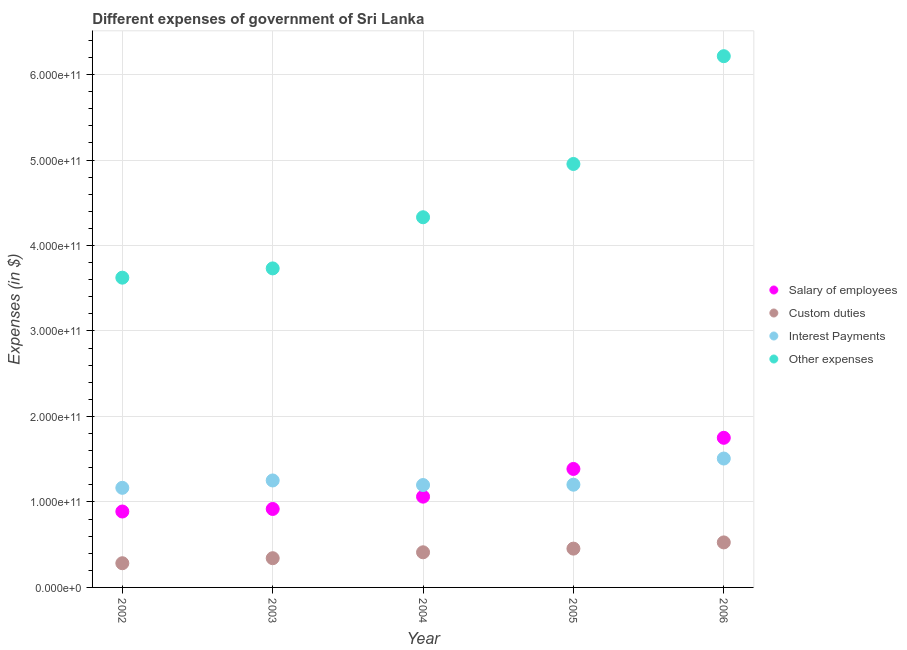How many different coloured dotlines are there?
Offer a terse response. 4. What is the amount spent on other expenses in 2003?
Your answer should be very brief. 3.73e+11. Across all years, what is the maximum amount spent on salary of employees?
Give a very brief answer. 1.75e+11. Across all years, what is the minimum amount spent on interest payments?
Your answer should be very brief. 1.17e+11. In which year was the amount spent on interest payments maximum?
Make the answer very short. 2006. In which year was the amount spent on custom duties minimum?
Your answer should be very brief. 2002. What is the total amount spent on salary of employees in the graph?
Ensure brevity in your answer.  6.00e+11. What is the difference between the amount spent on other expenses in 2002 and that in 2006?
Ensure brevity in your answer.  -2.59e+11. What is the difference between the amount spent on salary of employees in 2003 and the amount spent on interest payments in 2005?
Offer a very short reply. -2.84e+1. What is the average amount spent on interest payments per year?
Your response must be concise. 1.26e+11. In the year 2004, what is the difference between the amount spent on salary of employees and amount spent on custom duties?
Your answer should be compact. 6.51e+1. In how many years, is the amount spent on custom duties greater than 120000000000 $?
Ensure brevity in your answer.  0. What is the ratio of the amount spent on other expenses in 2004 to that in 2005?
Give a very brief answer. 0.87. Is the amount spent on custom duties in 2004 less than that in 2005?
Provide a succinct answer. Yes. What is the difference between the highest and the second highest amount spent on interest payments?
Make the answer very short. 2.57e+1. What is the difference between the highest and the lowest amount spent on interest payments?
Keep it short and to the point. 3.43e+1. Is it the case that in every year, the sum of the amount spent on custom duties and amount spent on salary of employees is greater than the sum of amount spent on interest payments and amount spent on other expenses?
Ensure brevity in your answer.  No. What is the difference between two consecutive major ticks on the Y-axis?
Offer a terse response. 1.00e+11. Are the values on the major ticks of Y-axis written in scientific E-notation?
Your answer should be compact. Yes. Does the graph contain grids?
Offer a terse response. Yes. How many legend labels are there?
Give a very brief answer. 4. How are the legend labels stacked?
Offer a terse response. Vertical. What is the title of the graph?
Offer a terse response. Different expenses of government of Sri Lanka. What is the label or title of the Y-axis?
Your answer should be compact. Expenses (in $). What is the Expenses (in $) of Salary of employees in 2002?
Give a very brief answer. 8.88e+1. What is the Expenses (in $) in Custom duties in 2002?
Ensure brevity in your answer.  2.83e+1. What is the Expenses (in $) of Interest Payments in 2002?
Give a very brief answer. 1.17e+11. What is the Expenses (in $) in Other expenses in 2002?
Your answer should be compact. 3.62e+11. What is the Expenses (in $) of Salary of employees in 2003?
Offer a very short reply. 9.18e+1. What is the Expenses (in $) of Custom duties in 2003?
Give a very brief answer. 3.42e+1. What is the Expenses (in $) in Interest Payments in 2003?
Keep it short and to the point. 1.25e+11. What is the Expenses (in $) in Other expenses in 2003?
Offer a terse response. 3.73e+11. What is the Expenses (in $) of Salary of employees in 2004?
Your response must be concise. 1.06e+11. What is the Expenses (in $) of Custom duties in 2004?
Provide a succinct answer. 4.11e+1. What is the Expenses (in $) of Interest Payments in 2004?
Provide a short and direct response. 1.20e+11. What is the Expenses (in $) of Other expenses in 2004?
Your answer should be compact. 4.33e+11. What is the Expenses (in $) in Salary of employees in 2005?
Provide a succinct answer. 1.39e+11. What is the Expenses (in $) in Custom duties in 2005?
Offer a terse response. 4.54e+1. What is the Expenses (in $) of Interest Payments in 2005?
Offer a terse response. 1.20e+11. What is the Expenses (in $) of Other expenses in 2005?
Offer a terse response. 4.95e+11. What is the Expenses (in $) of Salary of employees in 2006?
Give a very brief answer. 1.75e+11. What is the Expenses (in $) of Custom duties in 2006?
Ensure brevity in your answer.  5.27e+1. What is the Expenses (in $) in Interest Payments in 2006?
Your response must be concise. 1.51e+11. What is the Expenses (in $) of Other expenses in 2006?
Your answer should be compact. 6.21e+11. Across all years, what is the maximum Expenses (in $) in Salary of employees?
Make the answer very short. 1.75e+11. Across all years, what is the maximum Expenses (in $) in Custom duties?
Your answer should be very brief. 5.27e+1. Across all years, what is the maximum Expenses (in $) in Interest Payments?
Your response must be concise. 1.51e+11. Across all years, what is the maximum Expenses (in $) in Other expenses?
Ensure brevity in your answer.  6.21e+11. Across all years, what is the minimum Expenses (in $) of Salary of employees?
Your response must be concise. 8.88e+1. Across all years, what is the minimum Expenses (in $) of Custom duties?
Offer a very short reply. 2.83e+1. Across all years, what is the minimum Expenses (in $) of Interest Payments?
Your answer should be very brief. 1.17e+11. Across all years, what is the minimum Expenses (in $) in Other expenses?
Offer a very short reply. 3.62e+11. What is the total Expenses (in $) of Salary of employees in the graph?
Your answer should be very brief. 6.00e+11. What is the total Expenses (in $) in Custom duties in the graph?
Give a very brief answer. 2.02e+11. What is the total Expenses (in $) of Interest Payments in the graph?
Ensure brevity in your answer.  6.32e+11. What is the total Expenses (in $) in Other expenses in the graph?
Provide a short and direct response. 2.29e+12. What is the difference between the Expenses (in $) in Salary of employees in 2002 and that in 2003?
Make the answer very short. -2.98e+09. What is the difference between the Expenses (in $) of Custom duties in 2002 and that in 2003?
Your answer should be very brief. -5.88e+09. What is the difference between the Expenses (in $) in Interest Payments in 2002 and that in 2003?
Your answer should be compact. -8.61e+09. What is the difference between the Expenses (in $) in Other expenses in 2002 and that in 2003?
Offer a terse response. -1.08e+1. What is the difference between the Expenses (in $) of Salary of employees in 2002 and that in 2004?
Give a very brief answer. -1.74e+1. What is the difference between the Expenses (in $) in Custom duties in 2002 and that in 2004?
Your response must be concise. -1.28e+1. What is the difference between the Expenses (in $) of Interest Payments in 2002 and that in 2004?
Provide a succinct answer. -3.27e+09. What is the difference between the Expenses (in $) in Other expenses in 2002 and that in 2004?
Provide a short and direct response. -7.07e+1. What is the difference between the Expenses (in $) of Salary of employees in 2002 and that in 2005?
Provide a short and direct response. -4.98e+1. What is the difference between the Expenses (in $) of Custom duties in 2002 and that in 2005?
Offer a very short reply. -1.71e+1. What is the difference between the Expenses (in $) in Interest Payments in 2002 and that in 2005?
Make the answer very short. -3.64e+09. What is the difference between the Expenses (in $) of Other expenses in 2002 and that in 2005?
Provide a short and direct response. -1.33e+11. What is the difference between the Expenses (in $) of Salary of employees in 2002 and that in 2006?
Your response must be concise. -8.62e+1. What is the difference between the Expenses (in $) in Custom duties in 2002 and that in 2006?
Provide a short and direct response. -2.44e+1. What is the difference between the Expenses (in $) in Interest Payments in 2002 and that in 2006?
Provide a succinct answer. -3.43e+1. What is the difference between the Expenses (in $) of Other expenses in 2002 and that in 2006?
Your response must be concise. -2.59e+11. What is the difference between the Expenses (in $) in Salary of employees in 2003 and that in 2004?
Give a very brief answer. -1.44e+1. What is the difference between the Expenses (in $) in Custom duties in 2003 and that in 2004?
Your response must be concise. -6.91e+09. What is the difference between the Expenses (in $) in Interest Payments in 2003 and that in 2004?
Your answer should be very brief. 5.34e+09. What is the difference between the Expenses (in $) of Other expenses in 2003 and that in 2004?
Give a very brief answer. -5.98e+1. What is the difference between the Expenses (in $) in Salary of employees in 2003 and that in 2005?
Ensure brevity in your answer.  -4.68e+1. What is the difference between the Expenses (in $) in Custom duties in 2003 and that in 2005?
Keep it short and to the point. -1.12e+1. What is the difference between the Expenses (in $) in Interest Payments in 2003 and that in 2005?
Provide a succinct answer. 4.97e+09. What is the difference between the Expenses (in $) in Other expenses in 2003 and that in 2005?
Ensure brevity in your answer.  -1.22e+11. What is the difference between the Expenses (in $) in Salary of employees in 2003 and that in 2006?
Keep it short and to the point. -8.32e+1. What is the difference between the Expenses (in $) in Custom duties in 2003 and that in 2006?
Ensure brevity in your answer.  -1.85e+1. What is the difference between the Expenses (in $) in Interest Payments in 2003 and that in 2006?
Your answer should be very brief. -2.57e+1. What is the difference between the Expenses (in $) in Other expenses in 2003 and that in 2006?
Keep it short and to the point. -2.48e+11. What is the difference between the Expenses (in $) of Salary of employees in 2004 and that in 2005?
Provide a succinct answer. -3.24e+1. What is the difference between the Expenses (in $) of Custom duties in 2004 and that in 2005?
Your answer should be compact. -4.29e+09. What is the difference between the Expenses (in $) in Interest Payments in 2004 and that in 2005?
Ensure brevity in your answer.  -3.77e+08. What is the difference between the Expenses (in $) of Other expenses in 2004 and that in 2005?
Ensure brevity in your answer.  -6.23e+1. What is the difference between the Expenses (in $) in Salary of employees in 2004 and that in 2006?
Provide a short and direct response. -6.88e+1. What is the difference between the Expenses (in $) of Custom duties in 2004 and that in 2006?
Offer a very short reply. -1.16e+1. What is the difference between the Expenses (in $) of Interest Payments in 2004 and that in 2006?
Ensure brevity in your answer.  -3.10e+1. What is the difference between the Expenses (in $) of Other expenses in 2004 and that in 2006?
Provide a succinct answer. -1.88e+11. What is the difference between the Expenses (in $) of Salary of employees in 2005 and that in 2006?
Keep it short and to the point. -3.64e+1. What is the difference between the Expenses (in $) in Custom duties in 2005 and that in 2006?
Give a very brief answer. -7.27e+09. What is the difference between the Expenses (in $) of Interest Payments in 2005 and that in 2006?
Offer a terse response. -3.06e+1. What is the difference between the Expenses (in $) of Other expenses in 2005 and that in 2006?
Your answer should be compact. -1.26e+11. What is the difference between the Expenses (in $) of Salary of employees in 2002 and the Expenses (in $) of Custom duties in 2003?
Your answer should be compact. 5.46e+1. What is the difference between the Expenses (in $) of Salary of employees in 2002 and the Expenses (in $) of Interest Payments in 2003?
Your answer should be compact. -3.63e+1. What is the difference between the Expenses (in $) of Salary of employees in 2002 and the Expenses (in $) of Other expenses in 2003?
Give a very brief answer. -2.84e+11. What is the difference between the Expenses (in $) of Custom duties in 2002 and the Expenses (in $) of Interest Payments in 2003?
Make the answer very short. -9.68e+1. What is the difference between the Expenses (in $) in Custom duties in 2002 and the Expenses (in $) in Other expenses in 2003?
Give a very brief answer. -3.45e+11. What is the difference between the Expenses (in $) in Interest Payments in 2002 and the Expenses (in $) in Other expenses in 2003?
Keep it short and to the point. -2.57e+11. What is the difference between the Expenses (in $) in Salary of employees in 2002 and the Expenses (in $) in Custom duties in 2004?
Offer a terse response. 4.77e+1. What is the difference between the Expenses (in $) in Salary of employees in 2002 and the Expenses (in $) in Interest Payments in 2004?
Ensure brevity in your answer.  -3.10e+1. What is the difference between the Expenses (in $) of Salary of employees in 2002 and the Expenses (in $) of Other expenses in 2004?
Ensure brevity in your answer.  -3.44e+11. What is the difference between the Expenses (in $) of Custom duties in 2002 and the Expenses (in $) of Interest Payments in 2004?
Your answer should be compact. -9.15e+1. What is the difference between the Expenses (in $) in Custom duties in 2002 and the Expenses (in $) in Other expenses in 2004?
Provide a succinct answer. -4.05e+11. What is the difference between the Expenses (in $) of Interest Payments in 2002 and the Expenses (in $) of Other expenses in 2004?
Ensure brevity in your answer.  -3.17e+11. What is the difference between the Expenses (in $) in Salary of employees in 2002 and the Expenses (in $) in Custom duties in 2005?
Give a very brief answer. 4.34e+1. What is the difference between the Expenses (in $) in Salary of employees in 2002 and the Expenses (in $) in Interest Payments in 2005?
Ensure brevity in your answer.  -3.14e+1. What is the difference between the Expenses (in $) of Salary of employees in 2002 and the Expenses (in $) of Other expenses in 2005?
Offer a very short reply. -4.07e+11. What is the difference between the Expenses (in $) in Custom duties in 2002 and the Expenses (in $) in Interest Payments in 2005?
Your answer should be compact. -9.19e+1. What is the difference between the Expenses (in $) in Custom duties in 2002 and the Expenses (in $) in Other expenses in 2005?
Keep it short and to the point. -4.67e+11. What is the difference between the Expenses (in $) of Interest Payments in 2002 and the Expenses (in $) of Other expenses in 2005?
Provide a short and direct response. -3.79e+11. What is the difference between the Expenses (in $) in Salary of employees in 2002 and the Expenses (in $) in Custom duties in 2006?
Your response must be concise. 3.61e+1. What is the difference between the Expenses (in $) of Salary of employees in 2002 and the Expenses (in $) of Interest Payments in 2006?
Make the answer very short. -6.20e+1. What is the difference between the Expenses (in $) of Salary of employees in 2002 and the Expenses (in $) of Other expenses in 2006?
Ensure brevity in your answer.  -5.33e+11. What is the difference between the Expenses (in $) in Custom duties in 2002 and the Expenses (in $) in Interest Payments in 2006?
Your answer should be very brief. -1.22e+11. What is the difference between the Expenses (in $) in Custom duties in 2002 and the Expenses (in $) in Other expenses in 2006?
Keep it short and to the point. -5.93e+11. What is the difference between the Expenses (in $) in Interest Payments in 2002 and the Expenses (in $) in Other expenses in 2006?
Offer a terse response. -5.05e+11. What is the difference between the Expenses (in $) in Salary of employees in 2003 and the Expenses (in $) in Custom duties in 2004?
Your answer should be compact. 5.07e+1. What is the difference between the Expenses (in $) of Salary of employees in 2003 and the Expenses (in $) of Interest Payments in 2004?
Offer a terse response. -2.80e+1. What is the difference between the Expenses (in $) in Salary of employees in 2003 and the Expenses (in $) in Other expenses in 2004?
Keep it short and to the point. -3.41e+11. What is the difference between the Expenses (in $) in Custom duties in 2003 and the Expenses (in $) in Interest Payments in 2004?
Give a very brief answer. -8.56e+1. What is the difference between the Expenses (in $) of Custom duties in 2003 and the Expenses (in $) of Other expenses in 2004?
Provide a short and direct response. -3.99e+11. What is the difference between the Expenses (in $) in Interest Payments in 2003 and the Expenses (in $) in Other expenses in 2004?
Provide a short and direct response. -3.08e+11. What is the difference between the Expenses (in $) in Salary of employees in 2003 and the Expenses (in $) in Custom duties in 2005?
Ensure brevity in your answer.  4.64e+1. What is the difference between the Expenses (in $) of Salary of employees in 2003 and the Expenses (in $) of Interest Payments in 2005?
Your answer should be very brief. -2.84e+1. What is the difference between the Expenses (in $) of Salary of employees in 2003 and the Expenses (in $) of Other expenses in 2005?
Offer a very short reply. -4.04e+11. What is the difference between the Expenses (in $) in Custom duties in 2003 and the Expenses (in $) in Interest Payments in 2005?
Ensure brevity in your answer.  -8.60e+1. What is the difference between the Expenses (in $) of Custom duties in 2003 and the Expenses (in $) of Other expenses in 2005?
Provide a short and direct response. -4.61e+11. What is the difference between the Expenses (in $) of Interest Payments in 2003 and the Expenses (in $) of Other expenses in 2005?
Make the answer very short. -3.70e+11. What is the difference between the Expenses (in $) in Salary of employees in 2003 and the Expenses (in $) in Custom duties in 2006?
Your answer should be very brief. 3.91e+1. What is the difference between the Expenses (in $) of Salary of employees in 2003 and the Expenses (in $) of Interest Payments in 2006?
Give a very brief answer. -5.90e+1. What is the difference between the Expenses (in $) in Salary of employees in 2003 and the Expenses (in $) in Other expenses in 2006?
Your answer should be compact. -5.30e+11. What is the difference between the Expenses (in $) in Custom duties in 2003 and the Expenses (in $) in Interest Payments in 2006?
Provide a short and direct response. -1.17e+11. What is the difference between the Expenses (in $) in Custom duties in 2003 and the Expenses (in $) in Other expenses in 2006?
Your response must be concise. -5.87e+11. What is the difference between the Expenses (in $) of Interest Payments in 2003 and the Expenses (in $) of Other expenses in 2006?
Make the answer very short. -4.96e+11. What is the difference between the Expenses (in $) in Salary of employees in 2004 and the Expenses (in $) in Custom duties in 2005?
Make the answer very short. 6.08e+1. What is the difference between the Expenses (in $) of Salary of employees in 2004 and the Expenses (in $) of Interest Payments in 2005?
Offer a terse response. -1.40e+1. What is the difference between the Expenses (in $) of Salary of employees in 2004 and the Expenses (in $) of Other expenses in 2005?
Make the answer very short. -3.89e+11. What is the difference between the Expenses (in $) in Custom duties in 2004 and the Expenses (in $) in Interest Payments in 2005?
Make the answer very short. -7.91e+1. What is the difference between the Expenses (in $) in Custom duties in 2004 and the Expenses (in $) in Other expenses in 2005?
Your answer should be compact. -4.54e+11. What is the difference between the Expenses (in $) of Interest Payments in 2004 and the Expenses (in $) of Other expenses in 2005?
Keep it short and to the point. -3.76e+11. What is the difference between the Expenses (in $) in Salary of employees in 2004 and the Expenses (in $) in Custom duties in 2006?
Keep it short and to the point. 5.35e+1. What is the difference between the Expenses (in $) in Salary of employees in 2004 and the Expenses (in $) in Interest Payments in 2006?
Offer a terse response. -4.46e+1. What is the difference between the Expenses (in $) of Salary of employees in 2004 and the Expenses (in $) of Other expenses in 2006?
Your answer should be very brief. -5.15e+11. What is the difference between the Expenses (in $) in Custom duties in 2004 and the Expenses (in $) in Interest Payments in 2006?
Offer a very short reply. -1.10e+11. What is the difference between the Expenses (in $) in Custom duties in 2004 and the Expenses (in $) in Other expenses in 2006?
Your answer should be very brief. -5.80e+11. What is the difference between the Expenses (in $) of Interest Payments in 2004 and the Expenses (in $) of Other expenses in 2006?
Your answer should be very brief. -5.02e+11. What is the difference between the Expenses (in $) in Salary of employees in 2005 and the Expenses (in $) in Custom duties in 2006?
Your response must be concise. 8.59e+1. What is the difference between the Expenses (in $) of Salary of employees in 2005 and the Expenses (in $) of Interest Payments in 2006?
Provide a short and direct response. -1.22e+1. What is the difference between the Expenses (in $) of Salary of employees in 2005 and the Expenses (in $) of Other expenses in 2006?
Provide a short and direct response. -4.83e+11. What is the difference between the Expenses (in $) in Custom duties in 2005 and the Expenses (in $) in Interest Payments in 2006?
Ensure brevity in your answer.  -1.05e+11. What is the difference between the Expenses (in $) of Custom duties in 2005 and the Expenses (in $) of Other expenses in 2006?
Keep it short and to the point. -5.76e+11. What is the difference between the Expenses (in $) of Interest Payments in 2005 and the Expenses (in $) of Other expenses in 2006?
Make the answer very short. -5.01e+11. What is the average Expenses (in $) in Salary of employees per year?
Your answer should be very brief. 1.20e+11. What is the average Expenses (in $) of Custom duties per year?
Offer a very short reply. 4.03e+1. What is the average Expenses (in $) in Interest Payments per year?
Offer a very short reply. 1.26e+11. What is the average Expenses (in $) in Other expenses per year?
Your response must be concise. 4.57e+11. In the year 2002, what is the difference between the Expenses (in $) in Salary of employees and Expenses (in $) in Custom duties?
Your response must be concise. 6.05e+1. In the year 2002, what is the difference between the Expenses (in $) of Salary of employees and Expenses (in $) of Interest Payments?
Provide a short and direct response. -2.77e+1. In the year 2002, what is the difference between the Expenses (in $) of Salary of employees and Expenses (in $) of Other expenses?
Ensure brevity in your answer.  -2.74e+11. In the year 2002, what is the difference between the Expenses (in $) in Custom duties and Expenses (in $) in Interest Payments?
Your answer should be compact. -8.82e+1. In the year 2002, what is the difference between the Expenses (in $) in Custom duties and Expenses (in $) in Other expenses?
Keep it short and to the point. -3.34e+11. In the year 2002, what is the difference between the Expenses (in $) in Interest Payments and Expenses (in $) in Other expenses?
Your response must be concise. -2.46e+11. In the year 2003, what is the difference between the Expenses (in $) of Salary of employees and Expenses (in $) of Custom duties?
Give a very brief answer. 5.76e+1. In the year 2003, what is the difference between the Expenses (in $) of Salary of employees and Expenses (in $) of Interest Payments?
Provide a succinct answer. -3.33e+1. In the year 2003, what is the difference between the Expenses (in $) of Salary of employees and Expenses (in $) of Other expenses?
Your response must be concise. -2.81e+11. In the year 2003, what is the difference between the Expenses (in $) of Custom duties and Expenses (in $) of Interest Payments?
Offer a very short reply. -9.09e+1. In the year 2003, what is the difference between the Expenses (in $) in Custom duties and Expenses (in $) in Other expenses?
Your response must be concise. -3.39e+11. In the year 2003, what is the difference between the Expenses (in $) in Interest Payments and Expenses (in $) in Other expenses?
Offer a terse response. -2.48e+11. In the year 2004, what is the difference between the Expenses (in $) in Salary of employees and Expenses (in $) in Custom duties?
Provide a succinct answer. 6.51e+1. In the year 2004, what is the difference between the Expenses (in $) of Salary of employees and Expenses (in $) of Interest Payments?
Make the answer very short. -1.36e+1. In the year 2004, what is the difference between the Expenses (in $) in Salary of employees and Expenses (in $) in Other expenses?
Make the answer very short. -3.27e+11. In the year 2004, what is the difference between the Expenses (in $) in Custom duties and Expenses (in $) in Interest Payments?
Offer a terse response. -7.87e+1. In the year 2004, what is the difference between the Expenses (in $) of Custom duties and Expenses (in $) of Other expenses?
Ensure brevity in your answer.  -3.92e+11. In the year 2004, what is the difference between the Expenses (in $) in Interest Payments and Expenses (in $) in Other expenses?
Offer a terse response. -3.13e+11. In the year 2005, what is the difference between the Expenses (in $) of Salary of employees and Expenses (in $) of Custom duties?
Provide a succinct answer. 9.32e+1. In the year 2005, what is the difference between the Expenses (in $) of Salary of employees and Expenses (in $) of Interest Payments?
Provide a short and direct response. 1.84e+1. In the year 2005, what is the difference between the Expenses (in $) in Salary of employees and Expenses (in $) in Other expenses?
Offer a terse response. -3.57e+11. In the year 2005, what is the difference between the Expenses (in $) in Custom duties and Expenses (in $) in Interest Payments?
Provide a short and direct response. -7.48e+1. In the year 2005, what is the difference between the Expenses (in $) of Custom duties and Expenses (in $) of Other expenses?
Your answer should be very brief. -4.50e+11. In the year 2005, what is the difference between the Expenses (in $) of Interest Payments and Expenses (in $) of Other expenses?
Give a very brief answer. -3.75e+11. In the year 2006, what is the difference between the Expenses (in $) in Salary of employees and Expenses (in $) in Custom duties?
Offer a very short reply. 1.22e+11. In the year 2006, what is the difference between the Expenses (in $) in Salary of employees and Expenses (in $) in Interest Payments?
Give a very brief answer. 2.43e+1. In the year 2006, what is the difference between the Expenses (in $) of Salary of employees and Expenses (in $) of Other expenses?
Make the answer very short. -4.46e+11. In the year 2006, what is the difference between the Expenses (in $) of Custom duties and Expenses (in $) of Interest Payments?
Your answer should be compact. -9.81e+1. In the year 2006, what is the difference between the Expenses (in $) of Custom duties and Expenses (in $) of Other expenses?
Your answer should be very brief. -5.69e+11. In the year 2006, what is the difference between the Expenses (in $) in Interest Payments and Expenses (in $) in Other expenses?
Keep it short and to the point. -4.71e+11. What is the ratio of the Expenses (in $) of Salary of employees in 2002 to that in 2003?
Make the answer very short. 0.97. What is the ratio of the Expenses (in $) in Custom duties in 2002 to that in 2003?
Give a very brief answer. 0.83. What is the ratio of the Expenses (in $) in Interest Payments in 2002 to that in 2003?
Provide a short and direct response. 0.93. What is the ratio of the Expenses (in $) in Salary of employees in 2002 to that in 2004?
Offer a very short reply. 0.84. What is the ratio of the Expenses (in $) of Custom duties in 2002 to that in 2004?
Offer a very short reply. 0.69. What is the ratio of the Expenses (in $) of Interest Payments in 2002 to that in 2004?
Offer a very short reply. 0.97. What is the ratio of the Expenses (in $) of Other expenses in 2002 to that in 2004?
Provide a short and direct response. 0.84. What is the ratio of the Expenses (in $) in Salary of employees in 2002 to that in 2005?
Keep it short and to the point. 0.64. What is the ratio of the Expenses (in $) in Custom duties in 2002 to that in 2005?
Make the answer very short. 0.62. What is the ratio of the Expenses (in $) of Interest Payments in 2002 to that in 2005?
Ensure brevity in your answer.  0.97. What is the ratio of the Expenses (in $) in Other expenses in 2002 to that in 2005?
Ensure brevity in your answer.  0.73. What is the ratio of the Expenses (in $) of Salary of employees in 2002 to that in 2006?
Your response must be concise. 0.51. What is the ratio of the Expenses (in $) of Custom duties in 2002 to that in 2006?
Offer a very short reply. 0.54. What is the ratio of the Expenses (in $) in Interest Payments in 2002 to that in 2006?
Your response must be concise. 0.77. What is the ratio of the Expenses (in $) in Other expenses in 2002 to that in 2006?
Offer a very short reply. 0.58. What is the ratio of the Expenses (in $) in Salary of employees in 2003 to that in 2004?
Give a very brief answer. 0.86. What is the ratio of the Expenses (in $) in Custom duties in 2003 to that in 2004?
Offer a very short reply. 0.83. What is the ratio of the Expenses (in $) in Interest Payments in 2003 to that in 2004?
Your answer should be very brief. 1.04. What is the ratio of the Expenses (in $) in Other expenses in 2003 to that in 2004?
Your response must be concise. 0.86. What is the ratio of the Expenses (in $) of Salary of employees in 2003 to that in 2005?
Provide a succinct answer. 0.66. What is the ratio of the Expenses (in $) of Custom duties in 2003 to that in 2005?
Your answer should be very brief. 0.75. What is the ratio of the Expenses (in $) in Interest Payments in 2003 to that in 2005?
Give a very brief answer. 1.04. What is the ratio of the Expenses (in $) in Other expenses in 2003 to that in 2005?
Keep it short and to the point. 0.75. What is the ratio of the Expenses (in $) of Salary of employees in 2003 to that in 2006?
Offer a very short reply. 0.52. What is the ratio of the Expenses (in $) of Custom duties in 2003 to that in 2006?
Provide a succinct answer. 0.65. What is the ratio of the Expenses (in $) of Interest Payments in 2003 to that in 2006?
Your answer should be compact. 0.83. What is the ratio of the Expenses (in $) in Other expenses in 2003 to that in 2006?
Make the answer very short. 0.6. What is the ratio of the Expenses (in $) in Salary of employees in 2004 to that in 2005?
Your answer should be compact. 0.77. What is the ratio of the Expenses (in $) of Custom duties in 2004 to that in 2005?
Your response must be concise. 0.91. What is the ratio of the Expenses (in $) of Interest Payments in 2004 to that in 2005?
Your answer should be compact. 1. What is the ratio of the Expenses (in $) in Other expenses in 2004 to that in 2005?
Make the answer very short. 0.87. What is the ratio of the Expenses (in $) of Salary of employees in 2004 to that in 2006?
Offer a very short reply. 0.61. What is the ratio of the Expenses (in $) of Custom duties in 2004 to that in 2006?
Provide a short and direct response. 0.78. What is the ratio of the Expenses (in $) of Interest Payments in 2004 to that in 2006?
Your response must be concise. 0.79. What is the ratio of the Expenses (in $) in Other expenses in 2004 to that in 2006?
Provide a short and direct response. 0.7. What is the ratio of the Expenses (in $) in Salary of employees in 2005 to that in 2006?
Offer a terse response. 0.79. What is the ratio of the Expenses (in $) of Custom duties in 2005 to that in 2006?
Keep it short and to the point. 0.86. What is the ratio of the Expenses (in $) of Interest Payments in 2005 to that in 2006?
Ensure brevity in your answer.  0.8. What is the ratio of the Expenses (in $) of Other expenses in 2005 to that in 2006?
Offer a very short reply. 0.8. What is the difference between the highest and the second highest Expenses (in $) of Salary of employees?
Offer a terse response. 3.64e+1. What is the difference between the highest and the second highest Expenses (in $) in Custom duties?
Offer a terse response. 7.27e+09. What is the difference between the highest and the second highest Expenses (in $) in Interest Payments?
Your response must be concise. 2.57e+1. What is the difference between the highest and the second highest Expenses (in $) in Other expenses?
Provide a short and direct response. 1.26e+11. What is the difference between the highest and the lowest Expenses (in $) of Salary of employees?
Your response must be concise. 8.62e+1. What is the difference between the highest and the lowest Expenses (in $) of Custom duties?
Offer a very short reply. 2.44e+1. What is the difference between the highest and the lowest Expenses (in $) of Interest Payments?
Make the answer very short. 3.43e+1. What is the difference between the highest and the lowest Expenses (in $) of Other expenses?
Keep it short and to the point. 2.59e+11. 